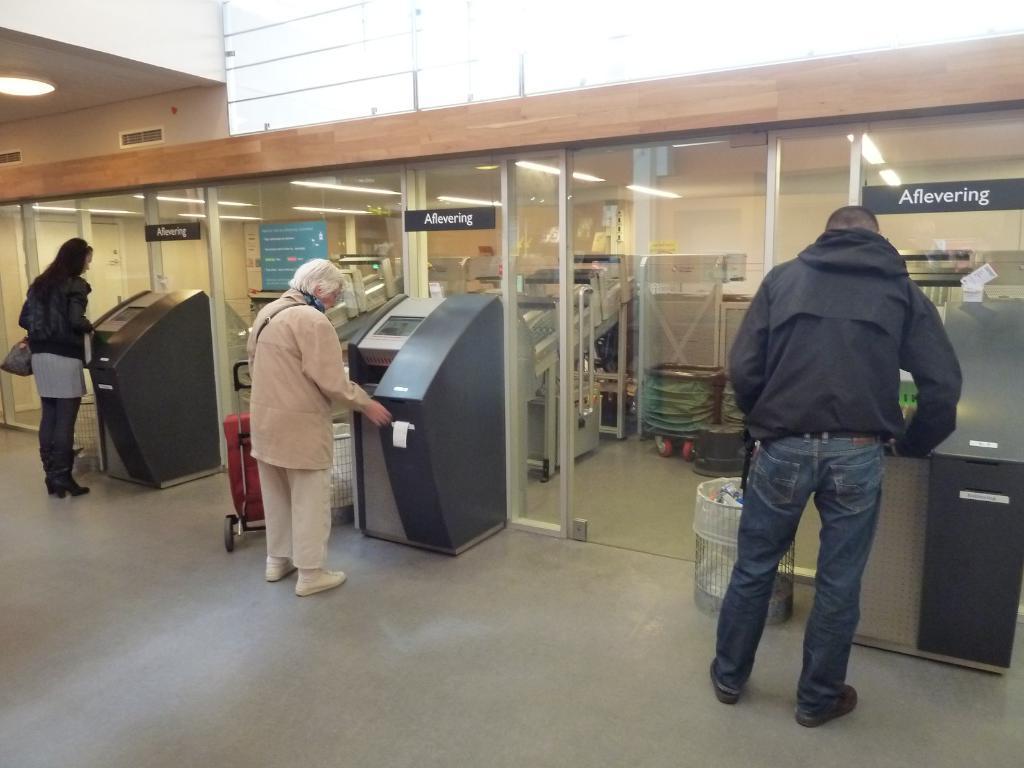In one or two sentences, can you explain what this image depicts? In this image there are people standing in front of the machines. Beside them there are dustbins. There are name boards on the glass doors. Through the glass doors we can see few objects. In the background of the image there is a wall. At the bottom of the image there is a floor. 